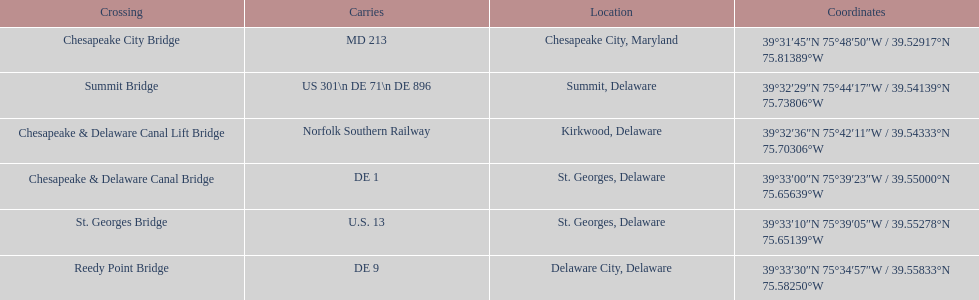Would you be able to parse every entry in this table? {'header': ['Crossing', 'Carries', 'Location', 'Coordinates'], 'rows': [['Chesapeake City Bridge', 'MD 213', 'Chesapeake City, Maryland', '39°31′45″N 75°48′50″W\ufeff / \ufeff39.52917°N 75.81389°W'], ['Summit Bridge', 'US 301\\n DE 71\\n DE 896', 'Summit, Delaware', '39°32′29″N 75°44′17″W\ufeff / \ufeff39.54139°N 75.73806°W'], ['Chesapeake & Delaware Canal Lift Bridge', 'Norfolk Southern Railway', 'Kirkwood, Delaware', '39°32′36″N 75°42′11″W\ufeff / \ufeff39.54333°N 75.70306°W'], ['Chesapeake & Delaware Canal Bridge', 'DE 1', 'St.\xa0Georges, Delaware', '39°33′00″N 75°39′23″W\ufeff / \ufeff39.55000°N 75.65639°W'], ['St.\xa0Georges Bridge', 'U.S.\xa013', 'St.\xa0Georges, Delaware', '39°33′10″N 75°39′05″W\ufeff / \ufeff39.55278°N 75.65139°W'], ['Reedy Point Bridge', 'DE\xa09', 'Delaware City, Delaware', '39°33′30″N 75°34′57″W\ufeff / \ufeff39.55833°N 75.58250°W']]} Which bridge is located in summit, delaware? Summit Bridge. 